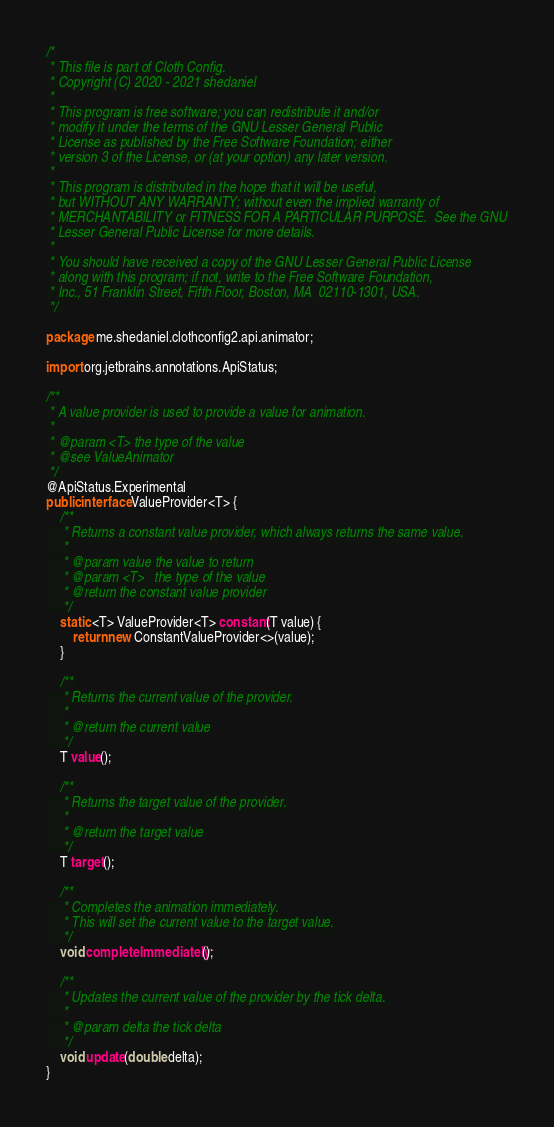Convert code to text. <code><loc_0><loc_0><loc_500><loc_500><_Java_>/*
 * This file is part of Cloth Config.
 * Copyright (C) 2020 - 2021 shedaniel
 *
 * This program is free software; you can redistribute it and/or
 * modify it under the terms of the GNU Lesser General Public
 * License as published by the Free Software Foundation; either
 * version 3 of the License, or (at your option) any later version.
 *
 * This program is distributed in the hope that it will be useful,
 * but WITHOUT ANY WARRANTY; without even the implied warranty of
 * MERCHANTABILITY or FITNESS FOR A PARTICULAR PURPOSE.  See the GNU
 * Lesser General Public License for more details.
 *
 * You should have received a copy of the GNU Lesser General Public License
 * along with this program; if not, write to the Free Software Foundation,
 * Inc., 51 Franklin Street, Fifth Floor, Boston, MA  02110-1301, USA.
 */

package me.shedaniel.clothconfig2.api.animator;

import org.jetbrains.annotations.ApiStatus;

/**
 * A value provider is used to provide a value for animation.
 *
 * @param <T> the type of the value
 * @see ValueAnimator
 */
@ApiStatus.Experimental
public interface ValueProvider<T> {
    /**
     * Returns a constant value provider, which always returns the same value.
     *
     * @param value the value to return
     * @param <T>   the type of the value
     * @return the constant value provider
     */
    static <T> ValueProvider<T> constant(T value) {
        return new ConstantValueProvider<>(value);
    }
    
    /**
     * Returns the current value of the provider.
     *
     * @return the current value
     */
    T value();
    
    /**
     * Returns the target value of the provider.
     *
     * @return the target value
     */
    T target();
    
    /**
     * Completes the animation immediately.
     * This will set the current value to the target value.
     */
    void completeImmediately();
    
    /**
     * Updates the current value of the provider by the tick delta.
     *
     * @param delta the tick delta
     */
    void update(double delta);
}
</code> 